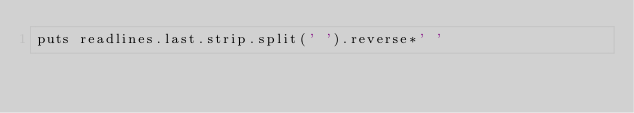Convert code to text. <code><loc_0><loc_0><loc_500><loc_500><_Ruby_>puts readlines.last.strip.split(' ').reverse*' '</code> 